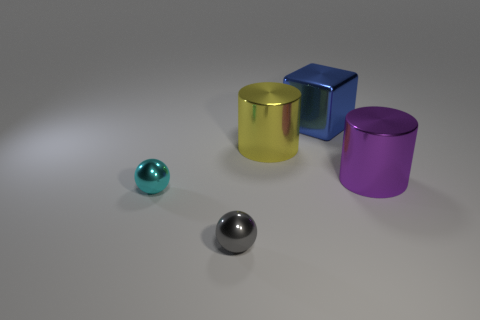Add 2 gray metal balls. How many objects exist? 7 Subtract all cubes. How many objects are left? 4 Add 2 big metal objects. How many big metal objects exist? 5 Subtract 0 red blocks. How many objects are left? 5 Subtract all big blocks. Subtract all tiny green metal cylinders. How many objects are left? 4 Add 4 large metallic things. How many large metallic things are left? 7 